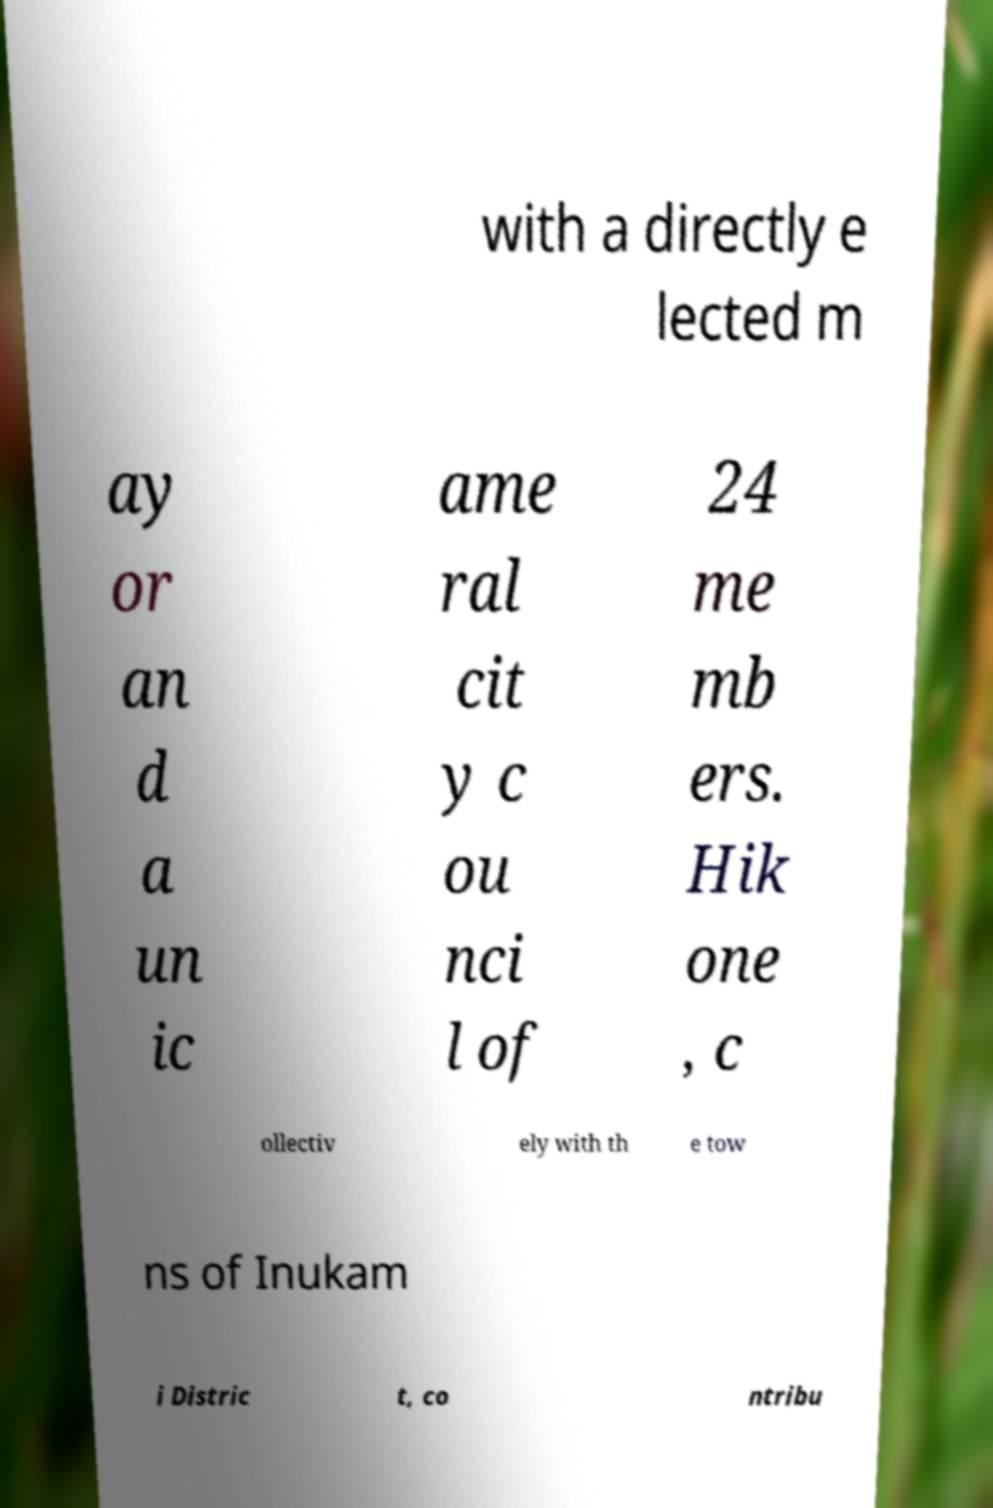Could you assist in decoding the text presented in this image and type it out clearly? with a directly e lected m ay or an d a un ic ame ral cit y c ou nci l of 24 me mb ers. Hik one , c ollectiv ely with th e tow ns of Inukam i Distric t, co ntribu 